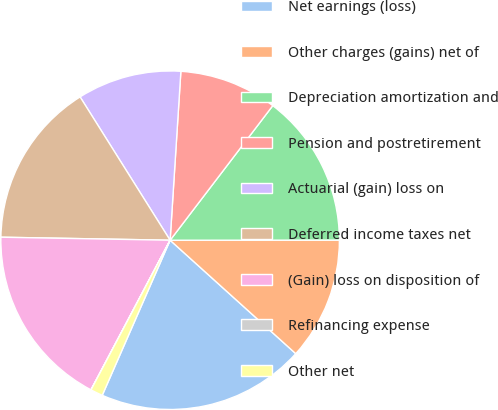<chart> <loc_0><loc_0><loc_500><loc_500><pie_chart><fcel>Net earnings (loss)<fcel>Other charges (gains) net of<fcel>Depreciation amortization and<fcel>Pension and postretirement<fcel>Actuarial (gain) loss on<fcel>Deferred income taxes net<fcel>(Gain) loss on disposition of<fcel>Refinancing expense<fcel>Other net<nl><fcel>19.88%<fcel>11.7%<fcel>14.62%<fcel>9.36%<fcel>9.94%<fcel>15.79%<fcel>17.54%<fcel>0.01%<fcel>1.17%<nl></chart> 